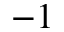<formula> <loc_0><loc_0><loc_500><loc_500>^ { - 1 }</formula> 